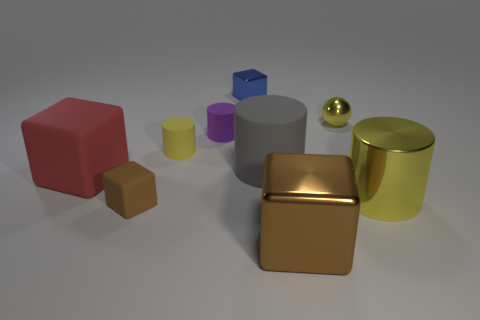Subtract all yellow cylinders. How many brown cubes are left? 2 Subtract 1 cylinders. How many cylinders are left? 3 Subtract all big brown shiny cubes. How many cubes are left? 3 Subtract all red cubes. How many cubes are left? 3 Subtract all blue cylinders. Subtract all purple balls. How many cylinders are left? 4 Subtract all balls. How many objects are left? 8 Add 5 tiny blue objects. How many tiny blue objects are left? 6 Add 7 yellow objects. How many yellow objects exist? 10 Subtract 0 green cylinders. How many objects are left? 9 Subtract all gray things. Subtract all purple matte cylinders. How many objects are left? 7 